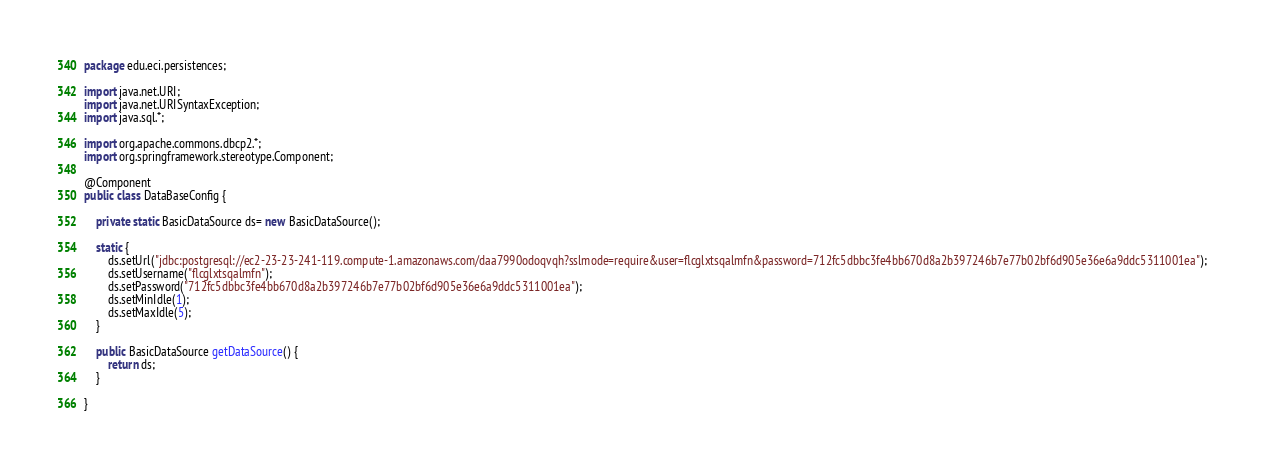Convert code to text. <code><loc_0><loc_0><loc_500><loc_500><_Java_>package edu.eci.persistences;

import java.net.URI;
import java.net.URISyntaxException;
import java.sql.*;

import org.apache.commons.dbcp2.*;
import org.springframework.stereotype.Component;

@Component
public class DataBaseConfig {
	
	private static BasicDataSource ds= new BasicDataSource();
	
	static {
		ds.setUrl("jdbc:postgresql://ec2-23-23-241-119.compute-1.amazonaws.com/daa7990odoqvqh?sslmode=require&user=flcglxtsqalmfn&password=712fc5dbbc3fe4bb670d8a2b397246b7e77b02bf6d905e36e6a9ddc5311001ea");
		ds.setUsername("flcglxtsqalmfn");
		ds.setPassword("712fc5dbbc3fe4bb670d8a2b397246b7e77b02bf6d905e36e6a9ddc5311001ea");
		ds.setMinIdle(1);
		ds.setMaxIdle(5);
	}
	
	public BasicDataSource getDataSource() {
		return ds;
	}

}</code> 